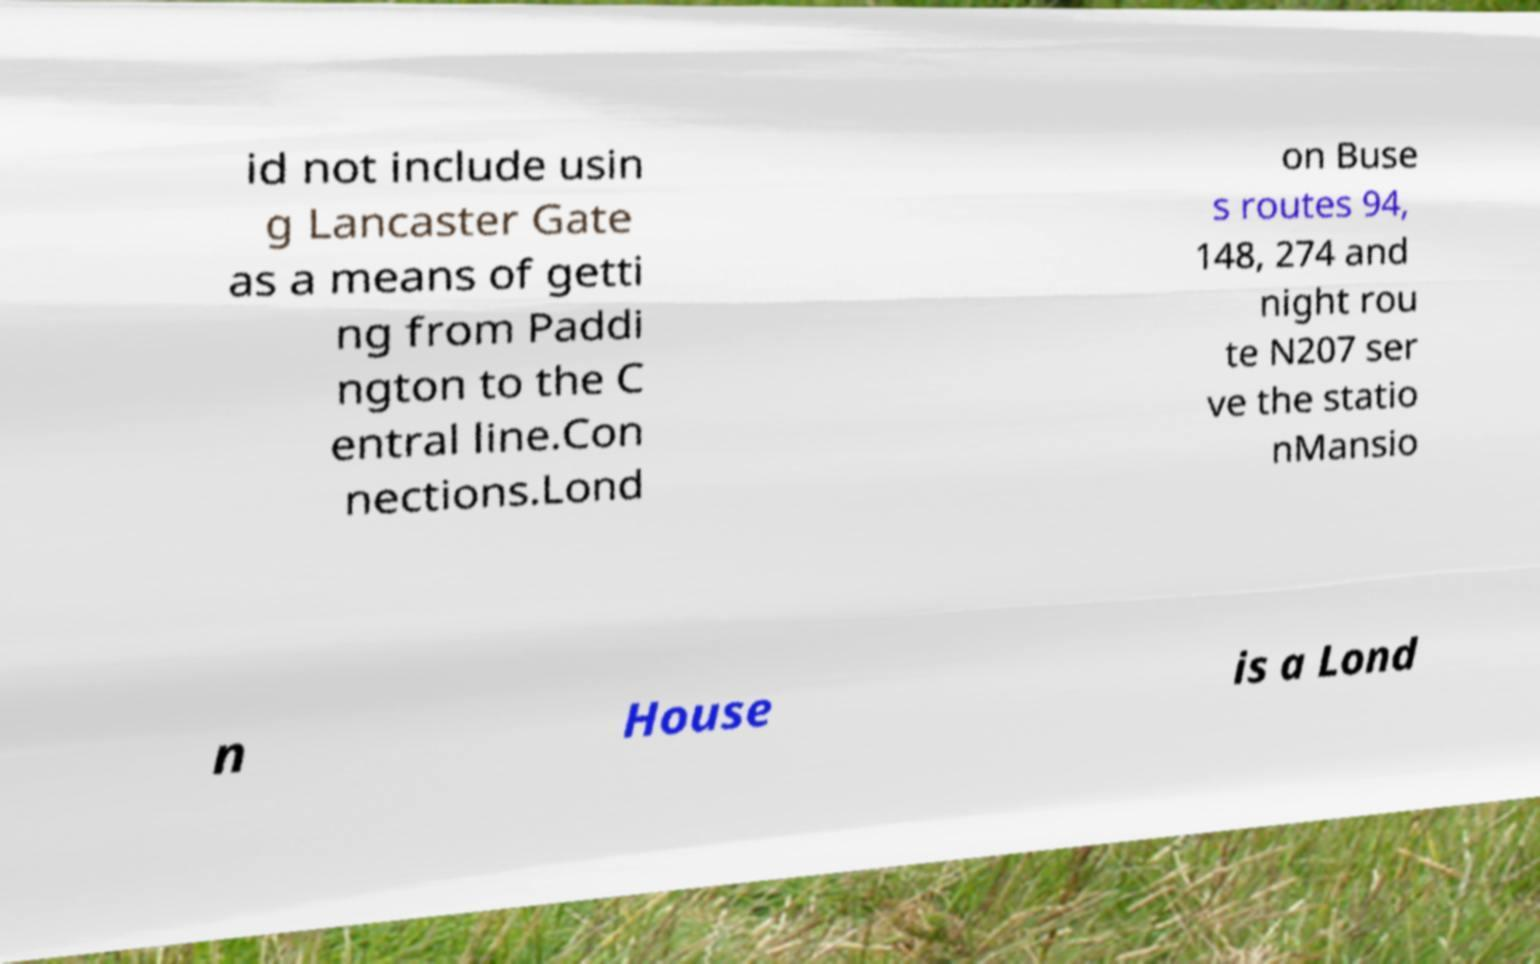Could you assist in decoding the text presented in this image and type it out clearly? id not include usin g Lancaster Gate as a means of getti ng from Paddi ngton to the C entral line.Con nections.Lond on Buse s routes 94, 148, 274 and night rou te N207 ser ve the statio nMansio n House is a Lond 